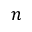Convert formula to latex. <formula><loc_0><loc_0><loc_500><loc_500>n</formula> 